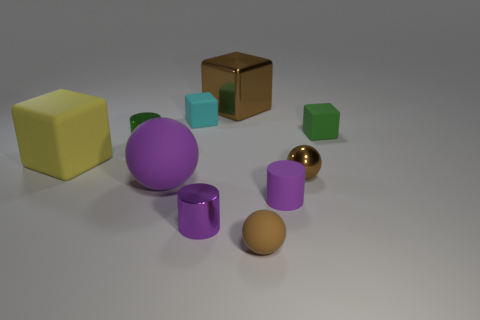Do the small ball that is in front of the big ball and the large metallic cube have the same color?
Offer a terse response. Yes. What material is the large ball that is the same color as the tiny matte cylinder?
Ensure brevity in your answer.  Rubber. What size is the cube that is the same color as the small matte ball?
Offer a very short reply. Large. There is a green thing to the left of the big purple rubber thing; what material is it?
Your answer should be very brief. Metal. What shape is the green thing that is behind the small cylinder on the left side of the ball to the left of the small brown rubber object?
Ensure brevity in your answer.  Cube. Does the brown metallic block have the same size as the brown shiny ball?
Keep it short and to the point. No. How many objects are yellow spheres or small green things to the left of the cyan thing?
Ensure brevity in your answer.  1. How many objects are small brown things in front of the large purple rubber thing or brown spheres that are in front of the purple sphere?
Provide a succinct answer. 1. There is a small cyan matte cube; are there any brown matte objects behind it?
Offer a very short reply. No. There is a cylinder that is behind the rubber sphere to the left of the brown thing in front of the large purple rubber object; what color is it?
Ensure brevity in your answer.  Green. 